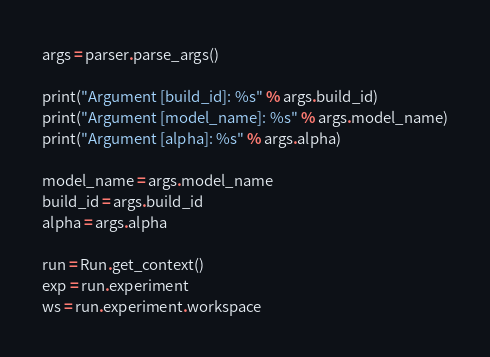Convert code to text. <code><loc_0><loc_0><loc_500><loc_500><_Python_>args = parser.parse_args()

print("Argument [build_id]: %s" % args.build_id)
print("Argument [model_name]: %s" % args.model_name)
print("Argument [alpha]: %s" % args.alpha)

model_name = args.model_name
build_id = args.build_id
alpha = args.alpha

run = Run.get_context()
exp = run.experiment
ws = run.experiment.workspace
</code> 